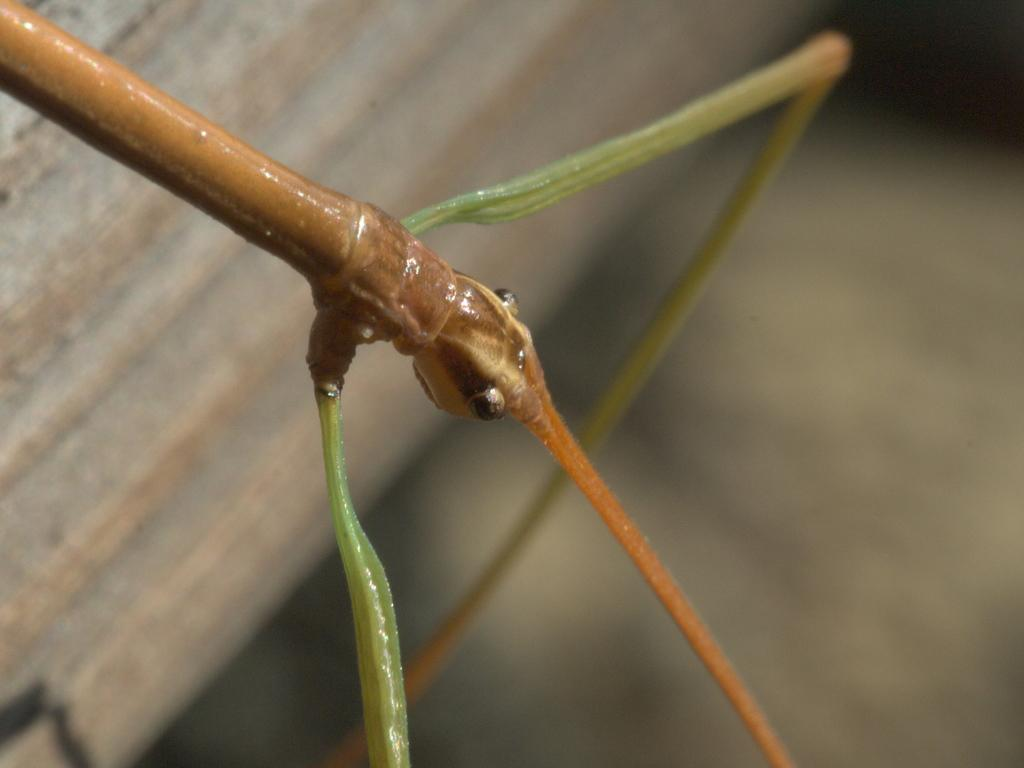What type of creature can be seen in the image? There is an insect in the image. Can you describe the background of the image? The background of the image is blurred. What type of leaf can be seen in the ear of the insect in the image? There is no leaf or ear present in the image; it features an insect with a blurred background. 